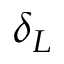Convert formula to latex. <formula><loc_0><loc_0><loc_500><loc_500>\delta _ { L }</formula> 